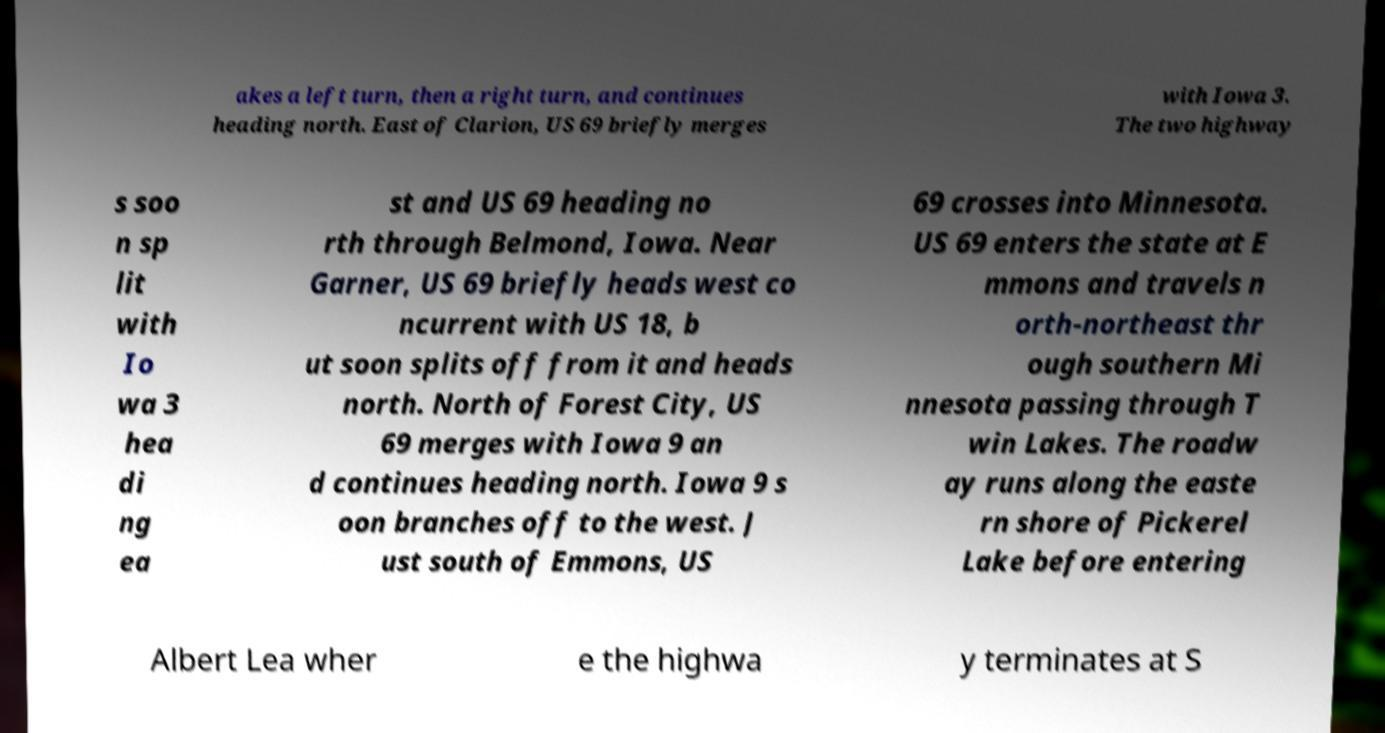For documentation purposes, I need the text within this image transcribed. Could you provide that? akes a left turn, then a right turn, and continues heading north. East of Clarion, US 69 briefly merges with Iowa 3. The two highway s soo n sp lit with Io wa 3 hea di ng ea st and US 69 heading no rth through Belmond, Iowa. Near Garner, US 69 briefly heads west co ncurrent with US 18, b ut soon splits off from it and heads north. North of Forest City, US 69 merges with Iowa 9 an d continues heading north. Iowa 9 s oon branches off to the west. J ust south of Emmons, US 69 crosses into Minnesota. US 69 enters the state at E mmons and travels n orth-northeast thr ough southern Mi nnesota passing through T win Lakes. The roadw ay runs along the easte rn shore of Pickerel Lake before entering Albert Lea wher e the highwa y terminates at S 